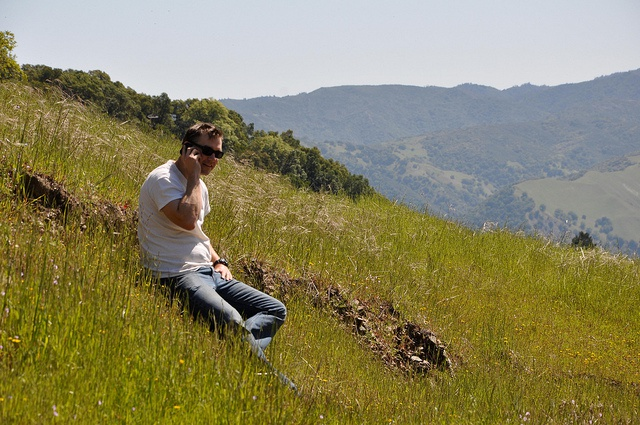Describe the objects in this image and their specific colors. I can see people in lightgray, gray, black, darkgray, and maroon tones and cell phone in black, maroon, and lightgray tones in this image. 